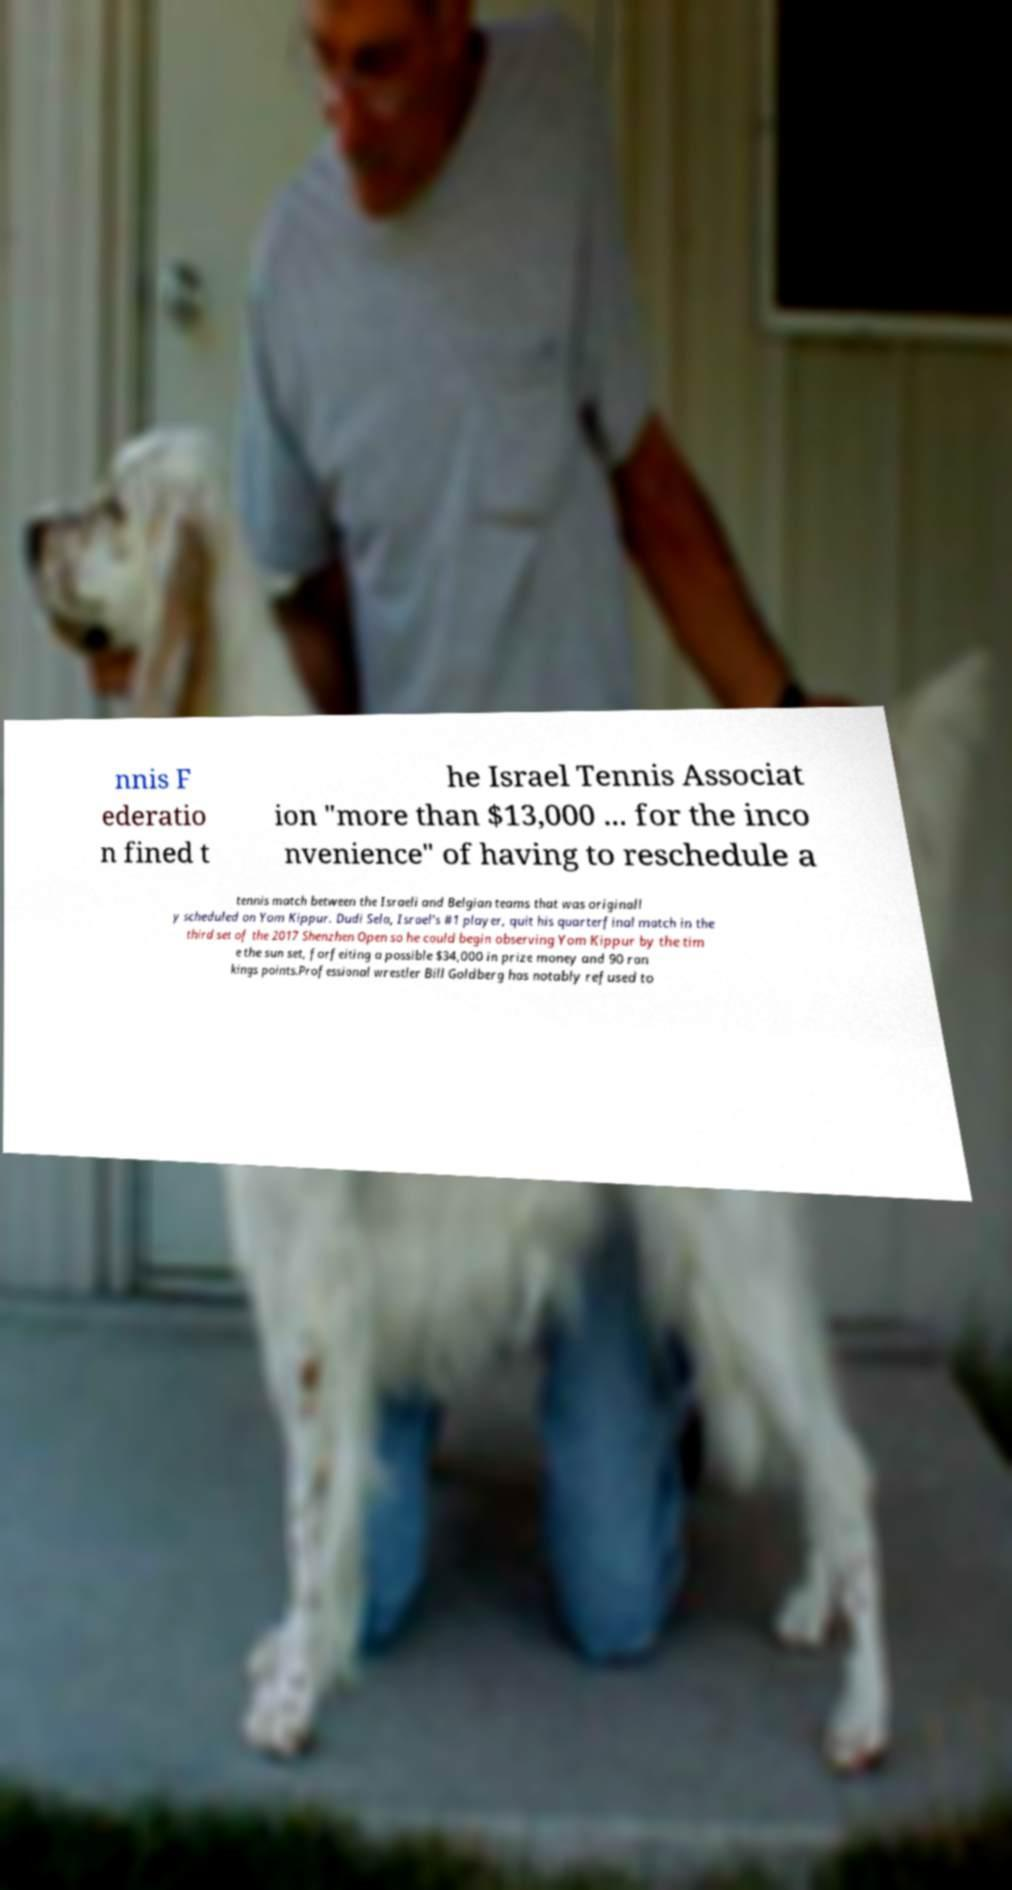Could you assist in decoding the text presented in this image and type it out clearly? nnis F ederatio n fined t he Israel Tennis Associat ion "more than $13,000 ... for the inco nvenience" of having to reschedule a tennis match between the Israeli and Belgian teams that was originall y scheduled on Yom Kippur. Dudi Sela, Israel's #1 player, quit his quarterfinal match in the third set of the 2017 Shenzhen Open so he could begin observing Yom Kippur by the tim e the sun set, forfeiting a possible $34,000 in prize money and 90 ran kings points.Professional wrestler Bill Goldberg has notably refused to 